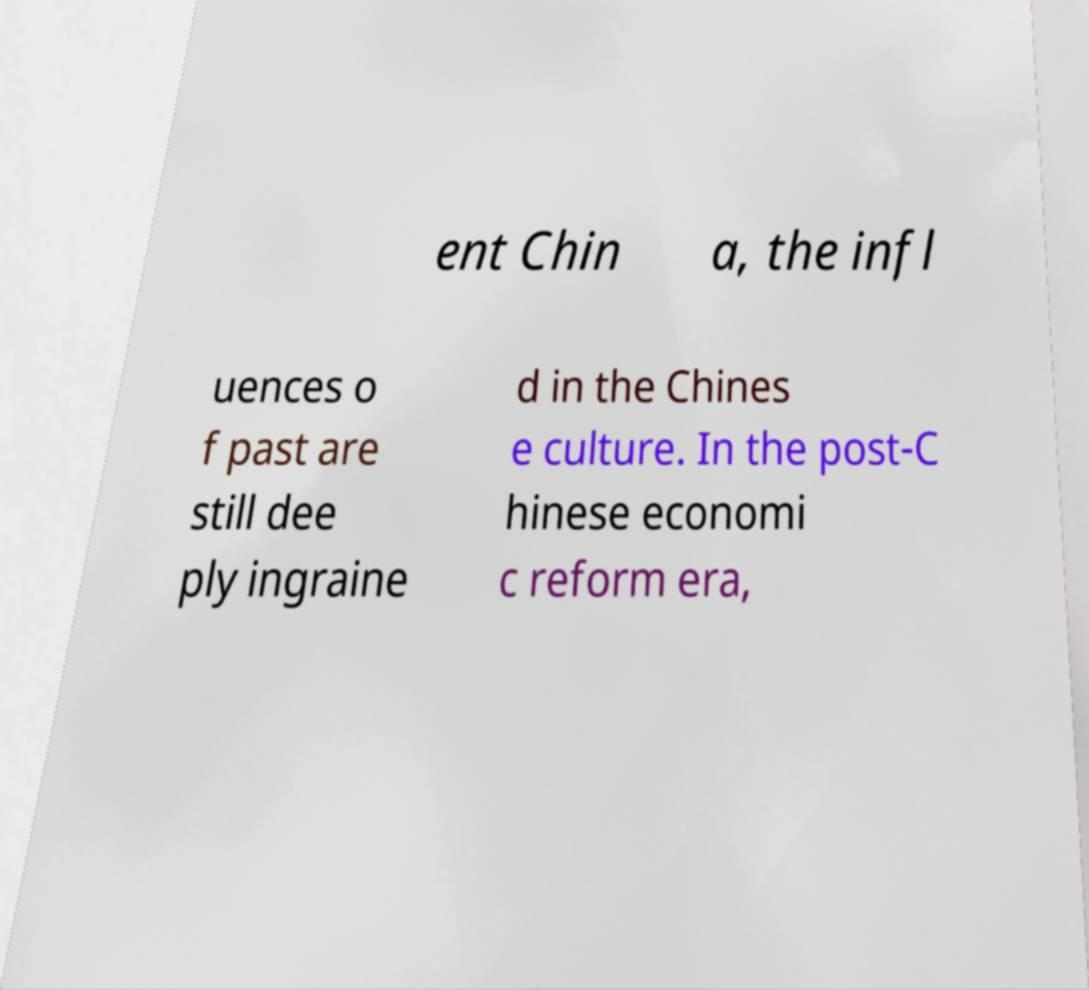Can you read and provide the text displayed in the image?This photo seems to have some interesting text. Can you extract and type it out for me? ent Chin a, the infl uences o f past are still dee ply ingraine d in the Chines e culture. In the post-C hinese economi c reform era, 